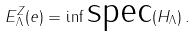Convert formula to latex. <formula><loc_0><loc_0><loc_500><loc_500>E ^ { Z } _ { \Lambda } ( e ) = \inf \text {spec} ( H _ { \Lambda } ) \, .</formula> 